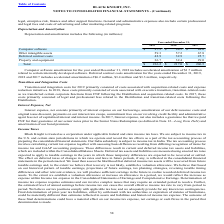According to Black Knight Financial Services's financial document, What was the amount of accelerated amortization included in Computer software amortization for the year ended 2018? According to the financial document, 1.7 (in millions). The relevant text states: "er 31, 2018 includes accelerated amortization of $1.7 million..." Also, What was the depreciation and amortization of computer software in 2017? According to the financial document, 84.0 (in millions). The relevant text states: "Computer software $ 97.3 $ 94.5 $ 84.0..." Also, What was the depreciation and amortization of deferred contract costs in 2019? According to the financial document, 42.9 (in millions). The relevant text states: "Deferred contract costs 42.9 32.9 25.7..." Also, can you calculate: What was the change in property and equipment between 2017 and 2018? Based on the calculation: 32.4-29.0, the result is 3.4 (in millions). This is based on the information: "Property and equipment 36.7 32.4 29.0 Property and equipment 36.7 32.4 29.0..." The key data points involved are: 29.0, 32.4. Additionally, Which years did Deferred contract costs exceed $30 million? The document shows two values: 2019 and 2018. From the document: "2019 2018 2017 2019 2018 2017..." Also, can you calculate: What was the percentage change in the total depreciation and amortization between 2018 and 2019? To answer this question, I need to perform calculations using the financial data. The calculation is: (236.2-217.0)/217.0, which equals 8.85 (percentage). This is based on the information: "Total $ 236.2 $ 217.0 $ 206.5 Total $ 236.2 $ 217.0 $ 206.5..." The key data points involved are: 217.0, 236.2. 